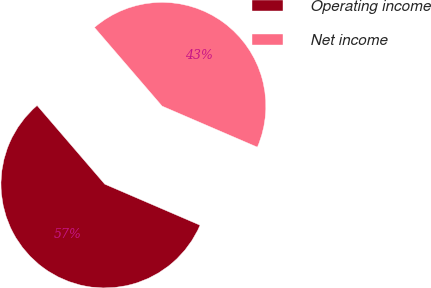Convert chart. <chart><loc_0><loc_0><loc_500><loc_500><pie_chart><fcel>Operating income<fcel>Net income<nl><fcel>57.22%<fcel>42.78%<nl></chart> 